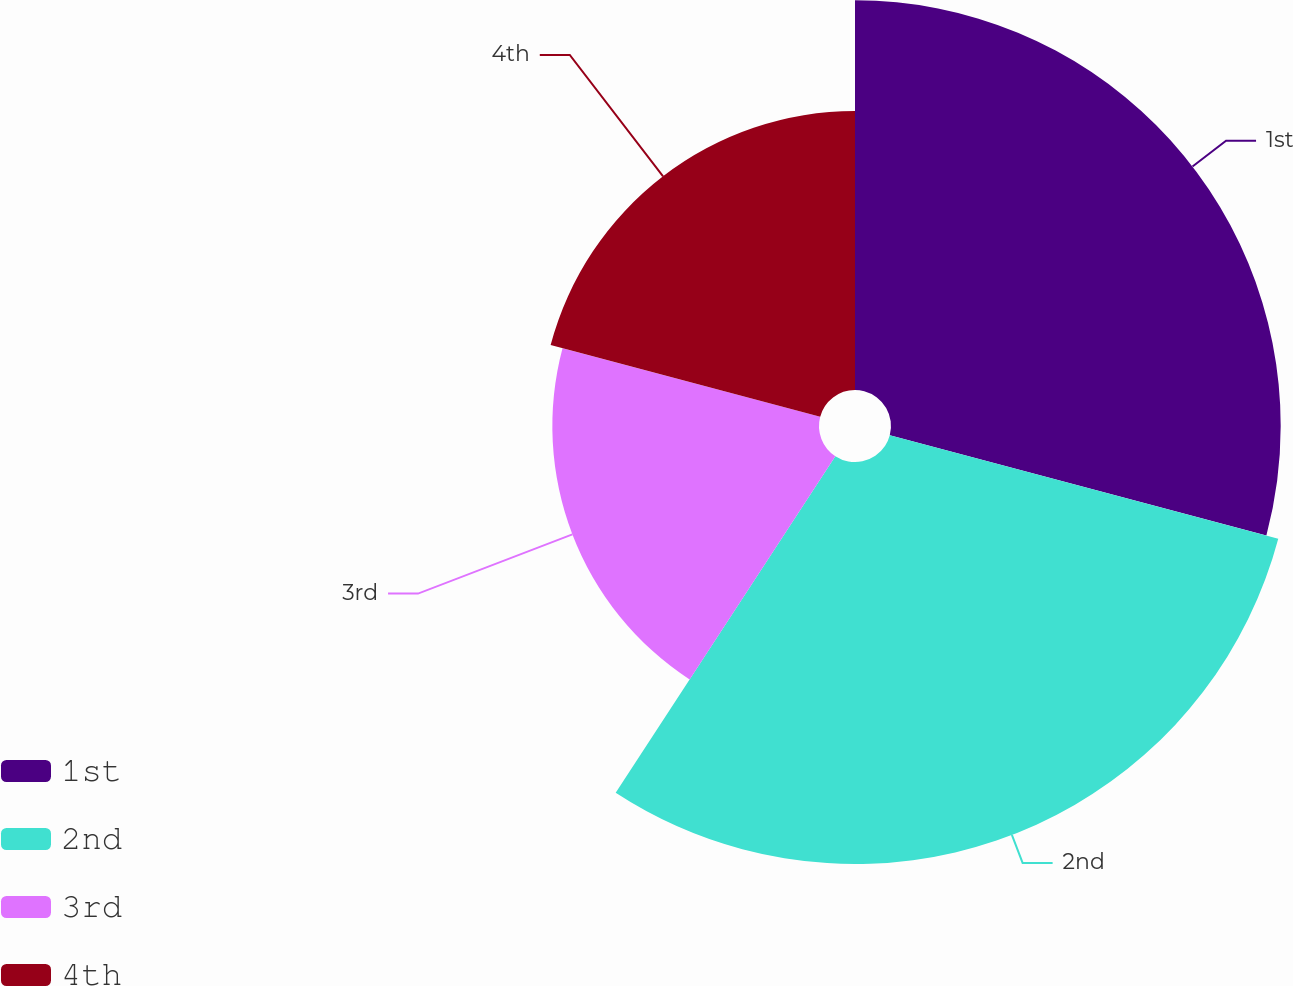<chart> <loc_0><loc_0><loc_500><loc_500><pie_chart><fcel>1st<fcel>2nd<fcel>3rd<fcel>4th<nl><fcel>29.14%<fcel>30.06%<fcel>19.94%<fcel>20.86%<nl></chart> 